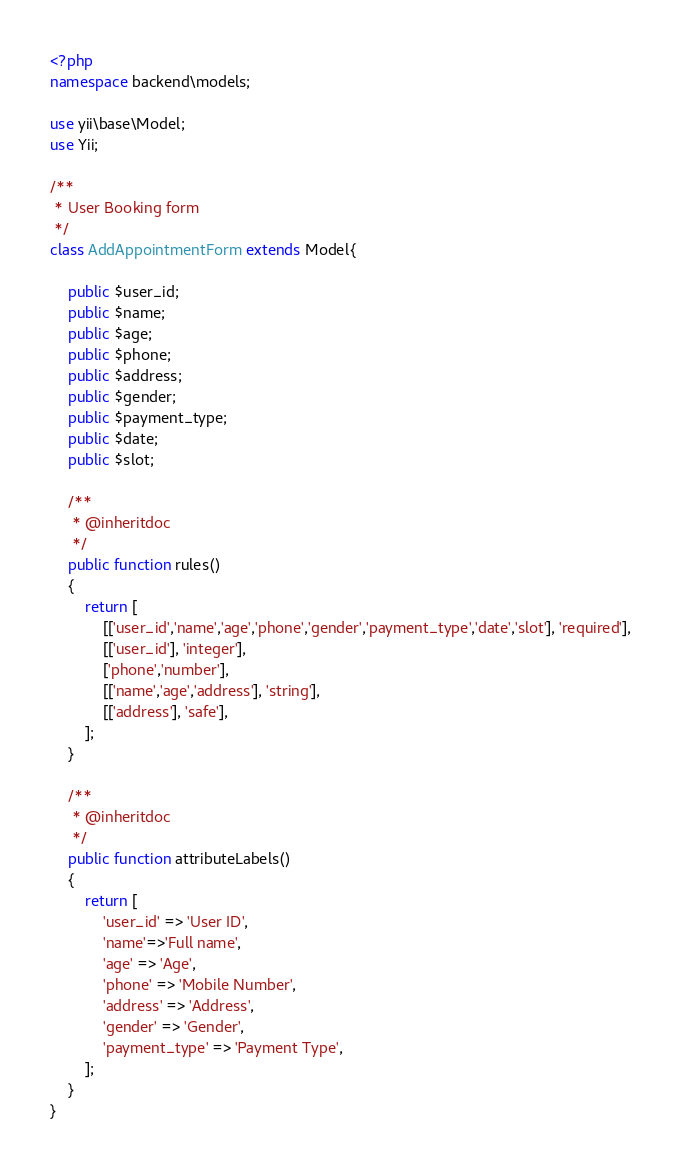Convert code to text. <code><loc_0><loc_0><loc_500><loc_500><_PHP_><?php
namespace backend\models;

use yii\base\Model;
use Yii;

/**
 * User Booking form
 */
class AddAppointmentForm extends Model{

    public $user_id;
    public $name;
    public $age;
    public $phone;
    public $address;
    public $gender;
    public $payment_type;
    public $date;
    public $slot;

    /**
     * @inheritdoc
     */
    public function rules()
    {
        return [
            [['user_id','name','age','phone','gender','payment_type','date','slot'], 'required'],
            [['user_id'], 'integer'],
            ['phone','number'],
            [['name','age','address'], 'string'],
            [['address'], 'safe'],
        ];
    }

    /**
     * @inheritdoc
     */
    public function attributeLabels()
    {
        return [
            'user_id' => 'User ID',
            'name'=>'Full name',
            'age' => 'Age',
            'phone' => 'Mobile Number',
            'address' => 'Address',
            'gender' => 'Gender',
            'payment_type' => 'Payment Type',
        ];
    }
}
</code> 